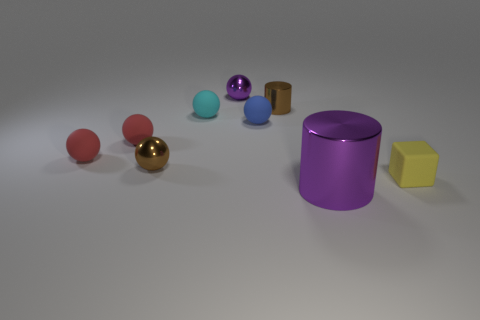How do the reflections on the spheres compare to those on the cylinder? The reflections on the spheres show a soft, diffused light, highlighting their smooth and curved surfaces. In contrast, the cylinder has a sharper, more defined reflection that accentuates its straight, vertical sides. 